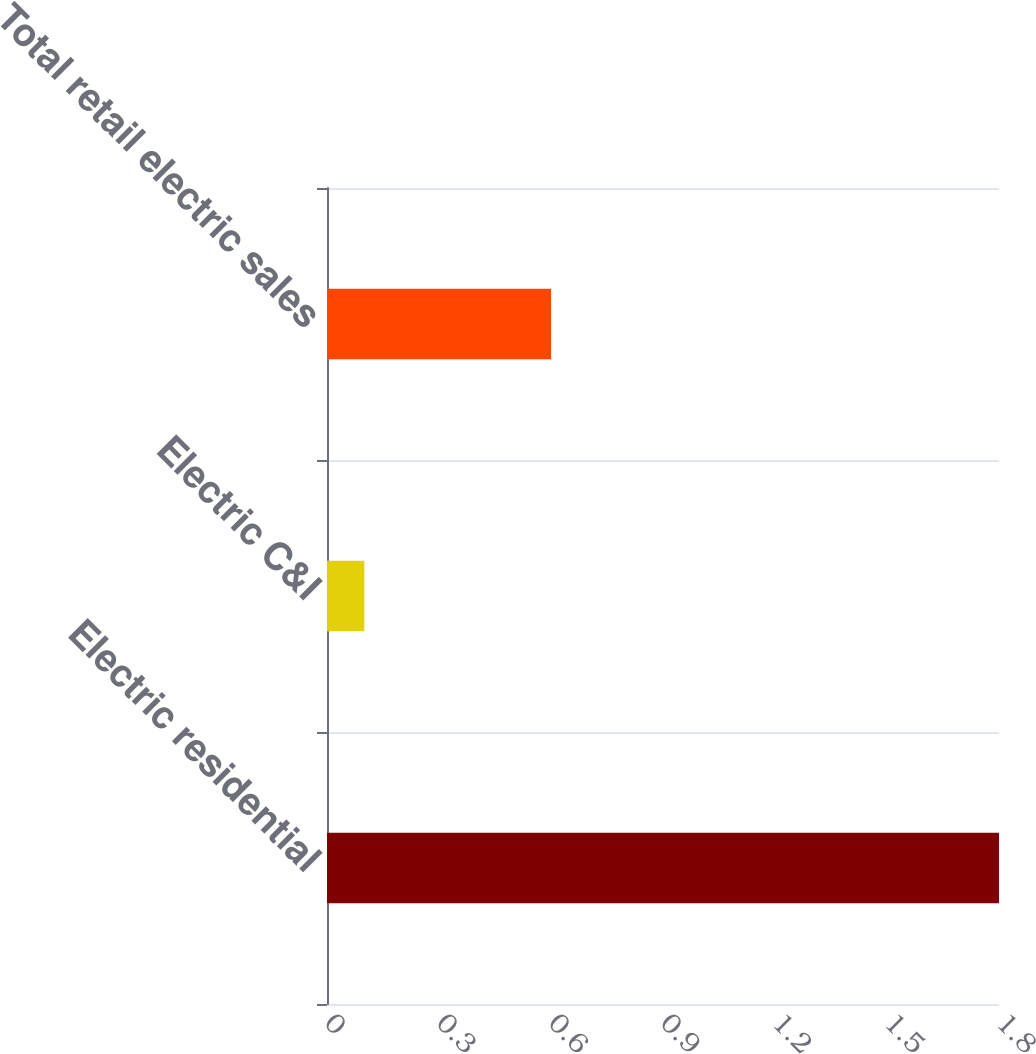Convert chart. <chart><loc_0><loc_0><loc_500><loc_500><bar_chart><fcel>Electric residential<fcel>Electric C&I<fcel>Total retail electric sales<nl><fcel>1.8<fcel>0.1<fcel>0.6<nl></chart> 